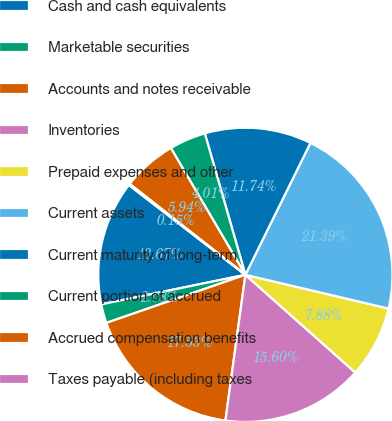Convert chart. <chart><loc_0><loc_0><loc_500><loc_500><pie_chart><fcel>Cash and cash equivalents<fcel>Marketable securities<fcel>Accounts and notes receivable<fcel>Inventories<fcel>Prepaid expenses and other<fcel>Current assets<fcel>Current maturity of long-term<fcel>Current portion of accrued<fcel>Accrued compensation benefits<fcel>Taxes payable (including taxes<nl><fcel>13.67%<fcel>2.08%<fcel>17.53%<fcel>15.6%<fcel>7.88%<fcel>21.39%<fcel>11.74%<fcel>4.01%<fcel>5.94%<fcel>0.15%<nl></chart> 